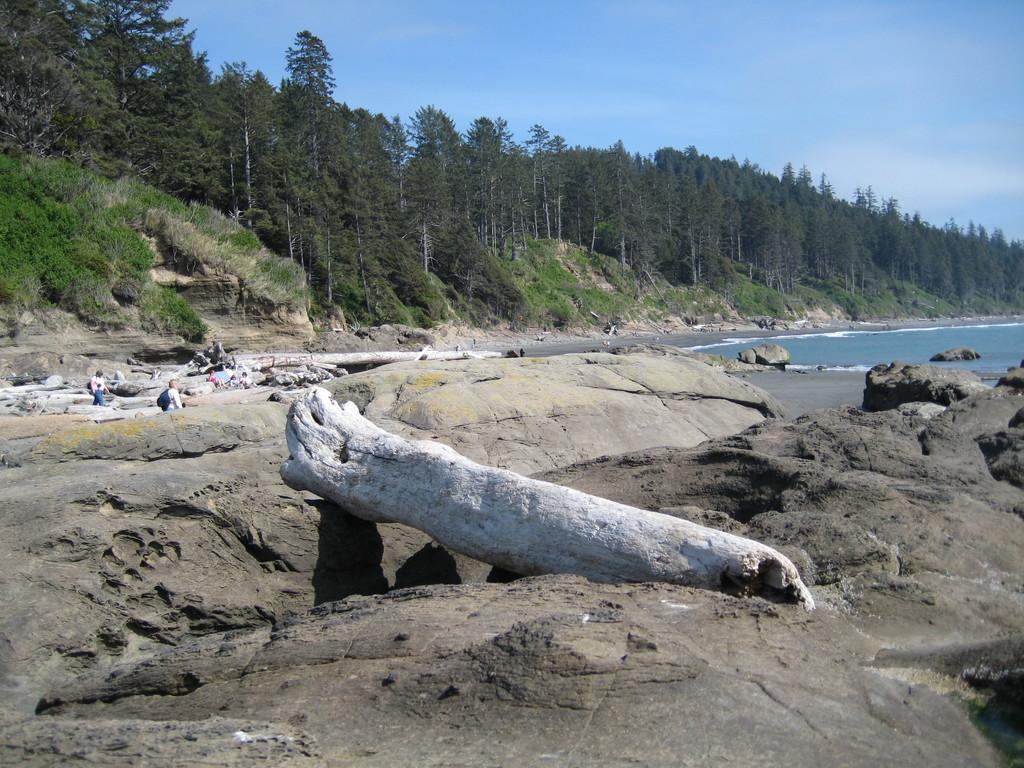Please provide a concise description of this image. This is an outside view. At the bottom there are many rocks and also I can see a trunk. On the right side there is an ocean. On the left side there are few people. In the background there are many trees. At the top of the image I can see the sky. 